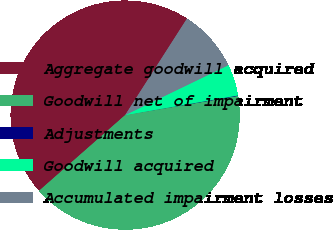<chart> <loc_0><loc_0><loc_500><loc_500><pie_chart><fcel>Aggregate goodwill acquired<fcel>Goodwill net of impairment<fcel>Adjustments<fcel>Goodwill acquired<fcel>Accumulated impairment losses<nl><fcel>45.55%<fcel>41.2%<fcel>0.07%<fcel>4.42%<fcel>8.77%<nl></chart> 